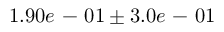<formula> <loc_0><loc_0><loc_500><loc_500>1 . 9 0 e - 0 1 \pm 3 . 0 e - 0 1</formula> 